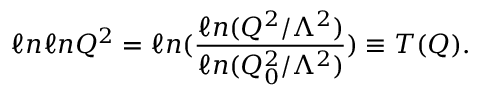Convert formula to latex. <formula><loc_0><loc_0><loc_500><loc_500>\ell n \ell n Q ^ { 2 } = \ell n ( \frac { \ell n ( Q ^ { 2 } / \Lambda ^ { 2 } ) } { \ell n ( Q _ { 0 } ^ { 2 } / \Lambda ^ { 2 } ) } ) \equiv T ( Q ) .</formula> 